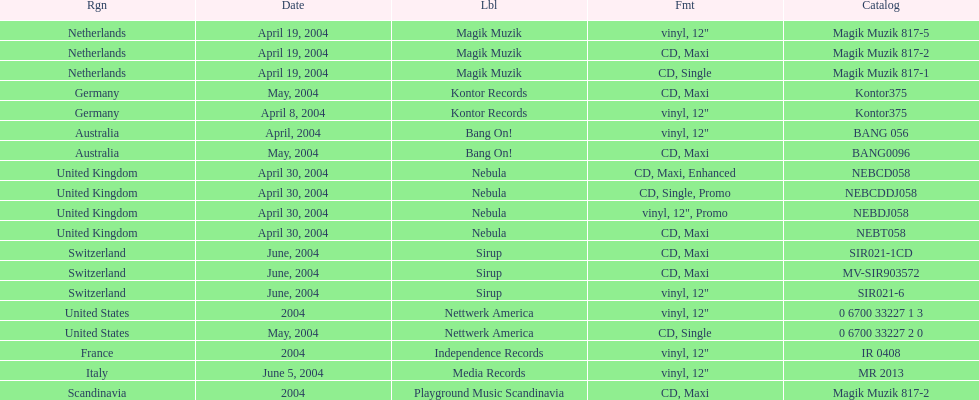What format did france use? Vinyl, 12". 